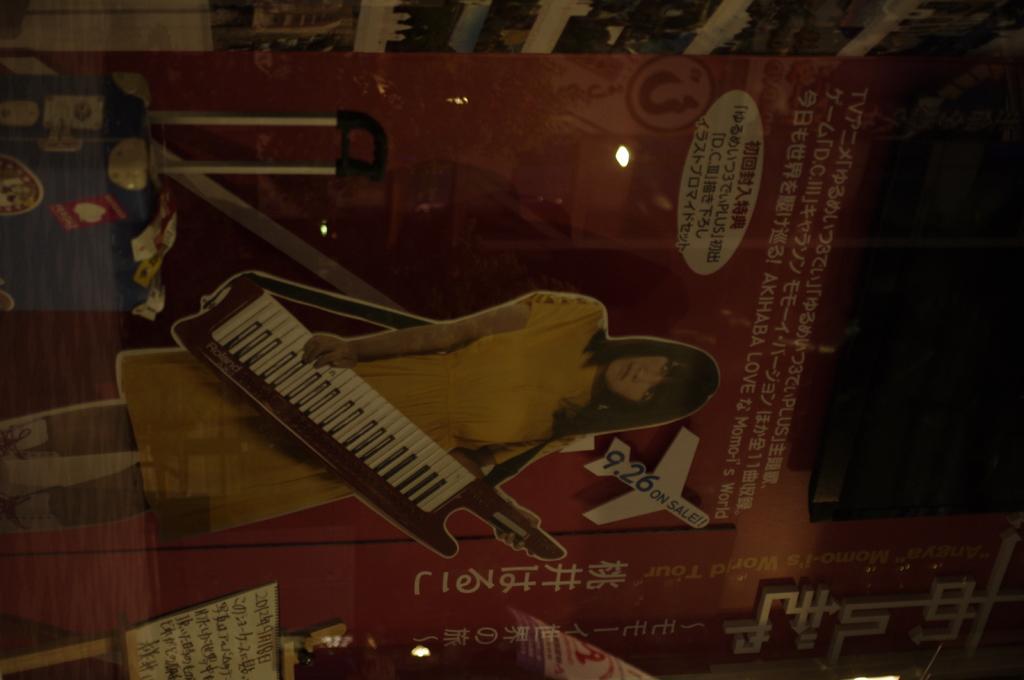Could you give a brief overview of what you see in this image? In this picture we can see pamphlet. In this pamphlet there is a woman who is wearing yellow dress and holding a piano. On the top we can see the racks. Here we can see some books. On the bottom left corner there is a board. 